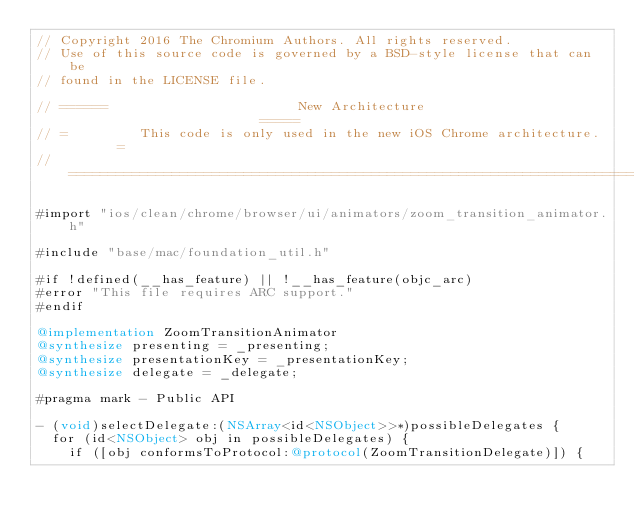Convert code to text. <code><loc_0><loc_0><loc_500><loc_500><_ObjectiveC_>// Copyright 2016 The Chromium Authors. All rights reserved.
// Use of this source code is governed by a BSD-style license that can be
// found in the LICENSE file.

// ======                        New Architecture                         =====
// =         This code is only used in the new iOS Chrome architecture.       =
// ============================================================================

#import "ios/clean/chrome/browser/ui/animators/zoom_transition_animator.h"

#include "base/mac/foundation_util.h"

#if !defined(__has_feature) || !__has_feature(objc_arc)
#error "This file requires ARC support."
#endif

@implementation ZoomTransitionAnimator
@synthesize presenting = _presenting;
@synthesize presentationKey = _presentationKey;
@synthesize delegate = _delegate;

#pragma mark - Public API

- (void)selectDelegate:(NSArray<id<NSObject>>*)possibleDelegates {
  for (id<NSObject> obj in possibleDelegates) {
    if ([obj conformsToProtocol:@protocol(ZoomTransitionDelegate)]) {</code> 